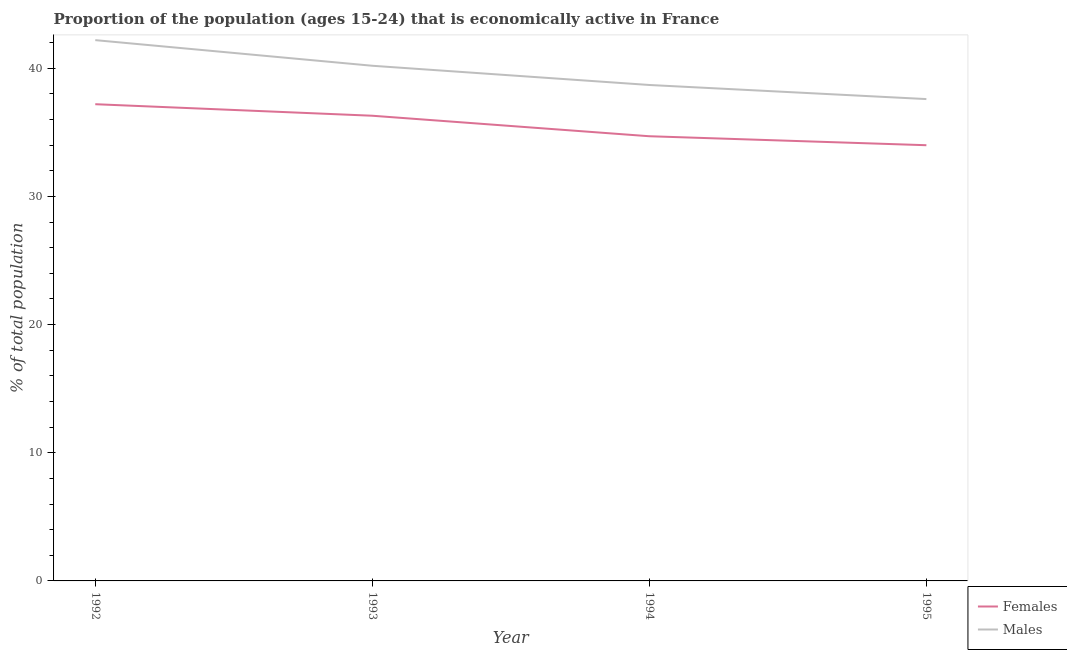How many different coloured lines are there?
Your answer should be very brief. 2. Does the line corresponding to percentage of economically active female population intersect with the line corresponding to percentage of economically active male population?
Offer a very short reply. No. What is the percentage of economically active female population in 1993?
Offer a very short reply. 36.3. Across all years, what is the maximum percentage of economically active female population?
Your response must be concise. 37.2. In which year was the percentage of economically active female population maximum?
Your answer should be very brief. 1992. In which year was the percentage of economically active male population minimum?
Ensure brevity in your answer.  1995. What is the total percentage of economically active male population in the graph?
Make the answer very short. 158.7. What is the difference between the percentage of economically active male population in 1993 and that in 1995?
Provide a short and direct response. 2.6. What is the difference between the percentage of economically active female population in 1994 and the percentage of economically active male population in 1992?
Offer a terse response. -7.5. What is the average percentage of economically active male population per year?
Offer a very short reply. 39.68. In the year 1995, what is the difference between the percentage of economically active female population and percentage of economically active male population?
Your answer should be compact. -3.6. In how many years, is the percentage of economically active male population greater than 34 %?
Give a very brief answer. 4. What is the ratio of the percentage of economically active male population in 1993 to that in 1995?
Provide a succinct answer. 1.07. What is the difference between the highest and the lowest percentage of economically active male population?
Your answer should be compact. 4.6. Is the percentage of economically active male population strictly greater than the percentage of economically active female population over the years?
Your response must be concise. Yes. How many lines are there?
Your answer should be very brief. 2. How many years are there in the graph?
Offer a terse response. 4. What is the difference between two consecutive major ticks on the Y-axis?
Your answer should be very brief. 10. Where does the legend appear in the graph?
Offer a very short reply. Bottom right. How are the legend labels stacked?
Give a very brief answer. Vertical. What is the title of the graph?
Make the answer very short. Proportion of the population (ages 15-24) that is economically active in France. What is the label or title of the Y-axis?
Your answer should be very brief. % of total population. What is the % of total population in Females in 1992?
Keep it short and to the point. 37.2. What is the % of total population in Males in 1992?
Your response must be concise. 42.2. What is the % of total population in Females in 1993?
Ensure brevity in your answer.  36.3. What is the % of total population of Males in 1993?
Keep it short and to the point. 40.2. What is the % of total population in Females in 1994?
Your answer should be compact. 34.7. What is the % of total population of Males in 1994?
Offer a very short reply. 38.7. What is the % of total population of Males in 1995?
Offer a very short reply. 37.6. Across all years, what is the maximum % of total population of Females?
Provide a short and direct response. 37.2. Across all years, what is the maximum % of total population in Males?
Give a very brief answer. 42.2. Across all years, what is the minimum % of total population of Females?
Your response must be concise. 34. Across all years, what is the minimum % of total population of Males?
Make the answer very short. 37.6. What is the total % of total population of Females in the graph?
Provide a short and direct response. 142.2. What is the total % of total population of Males in the graph?
Keep it short and to the point. 158.7. What is the difference between the % of total population in Males in 1992 and that in 1993?
Make the answer very short. 2. What is the difference between the % of total population of Females in 1992 and that in 1994?
Your answer should be compact. 2.5. What is the difference between the % of total population in Males in 1992 and that in 1994?
Give a very brief answer. 3.5. What is the difference between the % of total population in Females in 1992 and that in 1995?
Your response must be concise. 3.2. What is the difference between the % of total population in Males in 1992 and that in 1995?
Keep it short and to the point. 4.6. What is the difference between the % of total population in Females in 1993 and that in 1994?
Your answer should be compact. 1.6. What is the difference between the % of total population in Males in 1993 and that in 1994?
Make the answer very short. 1.5. What is the difference between the % of total population in Females in 1994 and that in 1995?
Provide a short and direct response. 0.7. What is the difference between the % of total population of Females in 1992 and the % of total population of Males in 1995?
Provide a succinct answer. -0.4. What is the difference between the % of total population of Females in 1994 and the % of total population of Males in 1995?
Offer a terse response. -2.9. What is the average % of total population in Females per year?
Keep it short and to the point. 35.55. What is the average % of total population in Males per year?
Offer a terse response. 39.67. In the year 1992, what is the difference between the % of total population in Females and % of total population in Males?
Offer a very short reply. -5. What is the ratio of the % of total population in Females in 1992 to that in 1993?
Your answer should be compact. 1.02. What is the ratio of the % of total population of Males in 1992 to that in 1993?
Provide a short and direct response. 1.05. What is the ratio of the % of total population in Females in 1992 to that in 1994?
Your answer should be compact. 1.07. What is the ratio of the % of total population of Males in 1992 to that in 1994?
Provide a short and direct response. 1.09. What is the ratio of the % of total population of Females in 1992 to that in 1995?
Ensure brevity in your answer.  1.09. What is the ratio of the % of total population of Males in 1992 to that in 1995?
Keep it short and to the point. 1.12. What is the ratio of the % of total population of Females in 1993 to that in 1994?
Your response must be concise. 1.05. What is the ratio of the % of total population of Males in 1993 to that in 1994?
Offer a terse response. 1.04. What is the ratio of the % of total population in Females in 1993 to that in 1995?
Provide a succinct answer. 1.07. What is the ratio of the % of total population of Males in 1993 to that in 1995?
Provide a succinct answer. 1.07. What is the ratio of the % of total population in Females in 1994 to that in 1995?
Provide a succinct answer. 1.02. What is the ratio of the % of total population in Males in 1994 to that in 1995?
Make the answer very short. 1.03. What is the difference between the highest and the second highest % of total population of Males?
Offer a terse response. 2. What is the difference between the highest and the lowest % of total population in Females?
Keep it short and to the point. 3.2. What is the difference between the highest and the lowest % of total population of Males?
Offer a terse response. 4.6. 